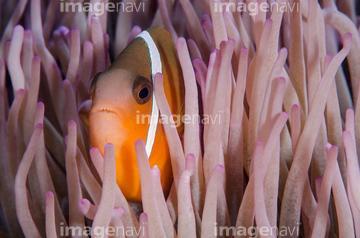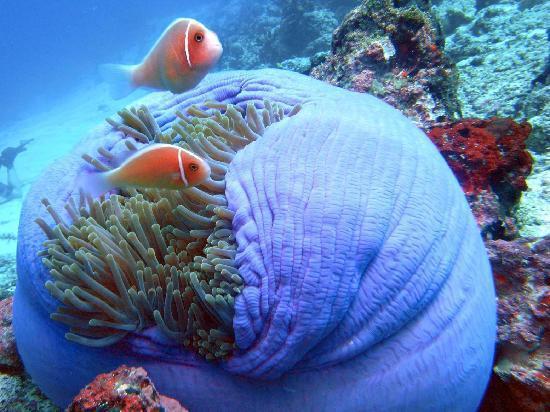The first image is the image on the left, the second image is the image on the right. Assess this claim about the two images: "Exactly two fish are seen hiding in the sea plant.". Correct or not? Answer yes or no. No. The first image is the image on the left, the second image is the image on the right. Evaluate the accuracy of this statement regarding the images: "Left image shows an orange fish with one white stripe swimming among lavender-colored tendrils.". Is it true? Answer yes or no. Yes. 